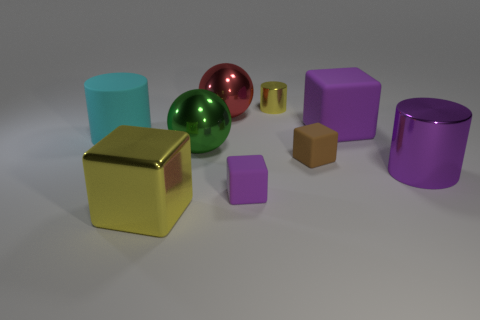There is a small object that is the same color as the metal cube; what is it made of?
Offer a terse response. Metal. Is the color of the large matte block the same as the big cylinder that is on the right side of the tiny purple matte cube?
Your answer should be compact. Yes. Are there fewer small brown things that are in front of the small brown object than cylinders left of the big green shiny thing?
Keep it short and to the point. Yes. There is another large object that is the same shape as the big red object; what material is it?
Your answer should be compact. Metal. Does the big shiny cube have the same color as the tiny cylinder?
Provide a short and direct response. Yes. There is a large purple thing that is the same material as the large yellow cube; what is its shape?
Provide a short and direct response. Cylinder. How many other shiny things have the same shape as the big cyan thing?
Provide a short and direct response. 2. The yellow thing that is on the left side of the purple object that is on the left side of the small metallic thing is what shape?
Make the answer very short. Cube. There is a purple object behind the purple cylinder; does it have the same size as the purple metal cylinder?
Offer a terse response. Yes. How big is the thing that is left of the large green sphere and in front of the purple cylinder?
Ensure brevity in your answer.  Large. 